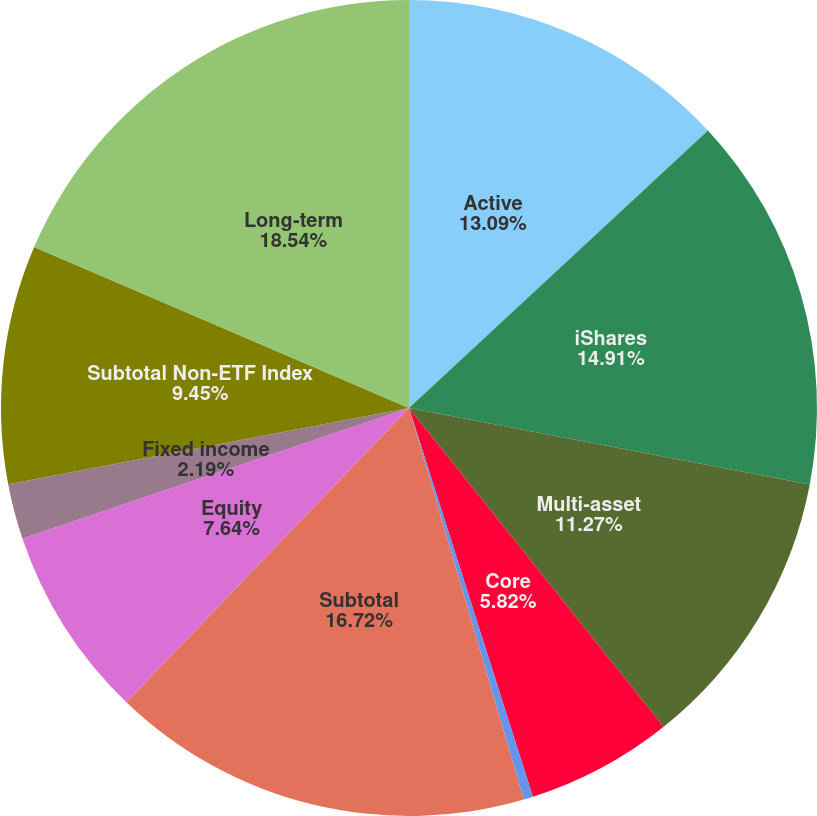Convert chart. <chart><loc_0><loc_0><loc_500><loc_500><pie_chart><fcel>Active<fcel>iShares<fcel>Multi-asset<fcel>Core<fcel>Currency and commodities<fcel>Subtotal<fcel>Equity<fcel>Fixed income<fcel>Subtotal Non-ETF Index<fcel>Long-term<nl><fcel>13.09%<fcel>14.91%<fcel>11.27%<fcel>5.82%<fcel>0.37%<fcel>16.72%<fcel>7.64%<fcel>2.19%<fcel>9.45%<fcel>18.54%<nl></chart> 